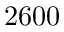Convert formula to latex. <formula><loc_0><loc_0><loc_500><loc_500>2 6 0 0</formula> 